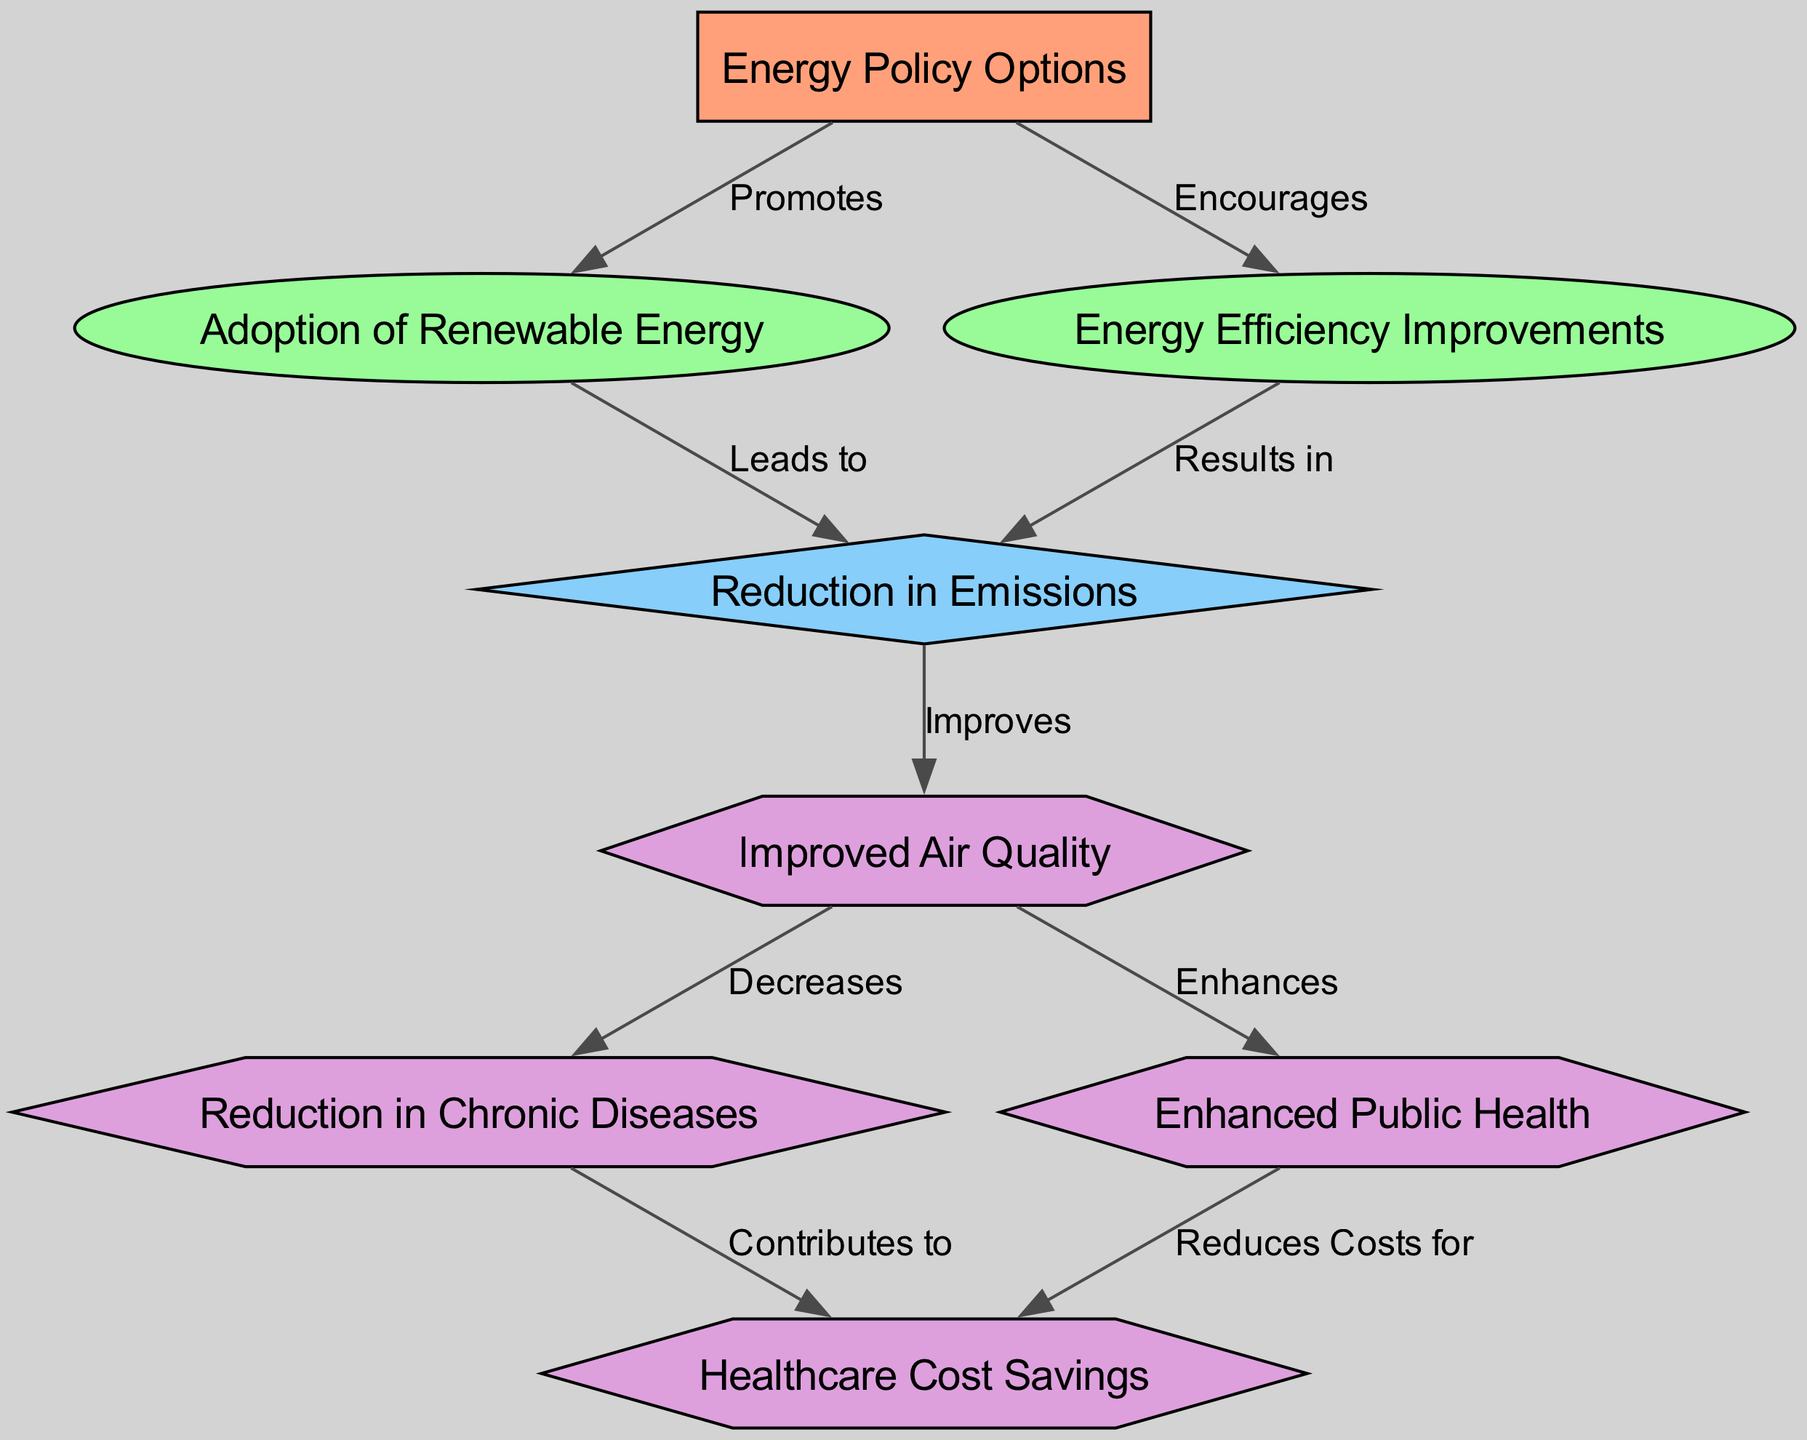What is the total number of nodes in the diagram? The diagram includes 8 distinct nodes: Energy Policy Options, Adoption of Renewable Energy, Energy Efficiency Improvements, Reduction in Emissions, Improved Air Quality, Healthcare Cost Savings, Reduction in Chronic Diseases, and Enhanced Public Health.
Answer: 8 What type of node is "Healthcare Cost Savings"? The node "Healthcare Cost Savings" is classified as an outcome type, represented in the diagram with a hexagon shape.
Answer: outcome What relationship is displayed between "Emission Reduction" and "Air Quality"? The edge labeled "Improves" connects the nodes "Emission Reduction" and "Air Quality," indicating that a reduction in emissions leads to improved air quality.
Answer: Improves Which measure directly leads to "Reduction in Chronic Diseases"? The node "Improved Air Quality" decreases the "Reduction in Chronic Diseases," suggesting that improved air quality has a direct influence on reducing chronic diseases.
Answer: Improved Air Quality What impact results from the "Adoption of Renewable Energy"? The diagram shows that the "Adoption of Renewable Energy" leads to a "Reduction in Emissions," indicating a connection where adopting renewable sources cuts emissions.
Answer: Reduction in Emissions How many edges connect to the "Public Health" node? The "Public Health" node has two incoming edges: one from "Air Quality" (labeled Enhances) and one going toward "Healthcare Cost Savings" (labeled Reduces Costs for), totaling two connections.
Answer: 2 What effect does "Air Quality" have on healthcare costs? The influence of "Air Quality" on healthcare costs is captured by the edge labeled "Reduces Costs for," linking "Public Health" to "Healthcare Cost Savings," hence indicating a negative impact on costs due to improved air quality.
Answer: Reduces Costs for Which node has the maximum outgoing relationships? The node "Air Quality" has two outgoing relationships: it enhances "Public Health" and decreases "Reduction in Chronic Diseases," showing it has the most outgoing connections in the diagram.
Answer: Air Quality What is the direct consequence of "Energy Efficiency Improvements"? The direct consequence of "Energy Efficiency Improvements" is a "Reduction in Emissions," indicating that improved energy efficiency results in lower emissions.
Answer: Reduction in Emissions 